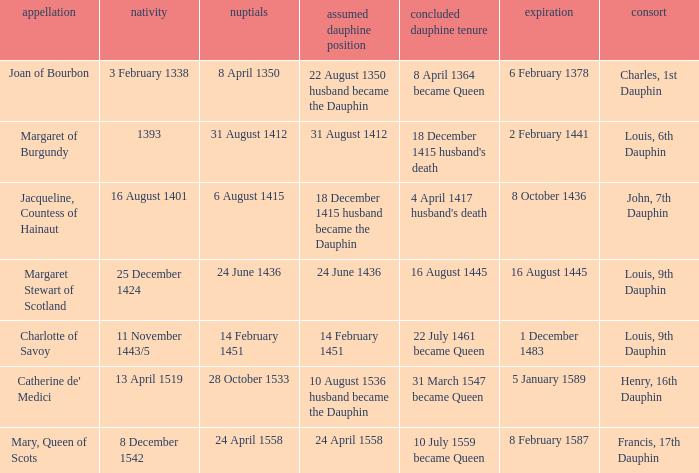When was the marriage when became dauphine is 31 august 1412? 31 August 1412. 